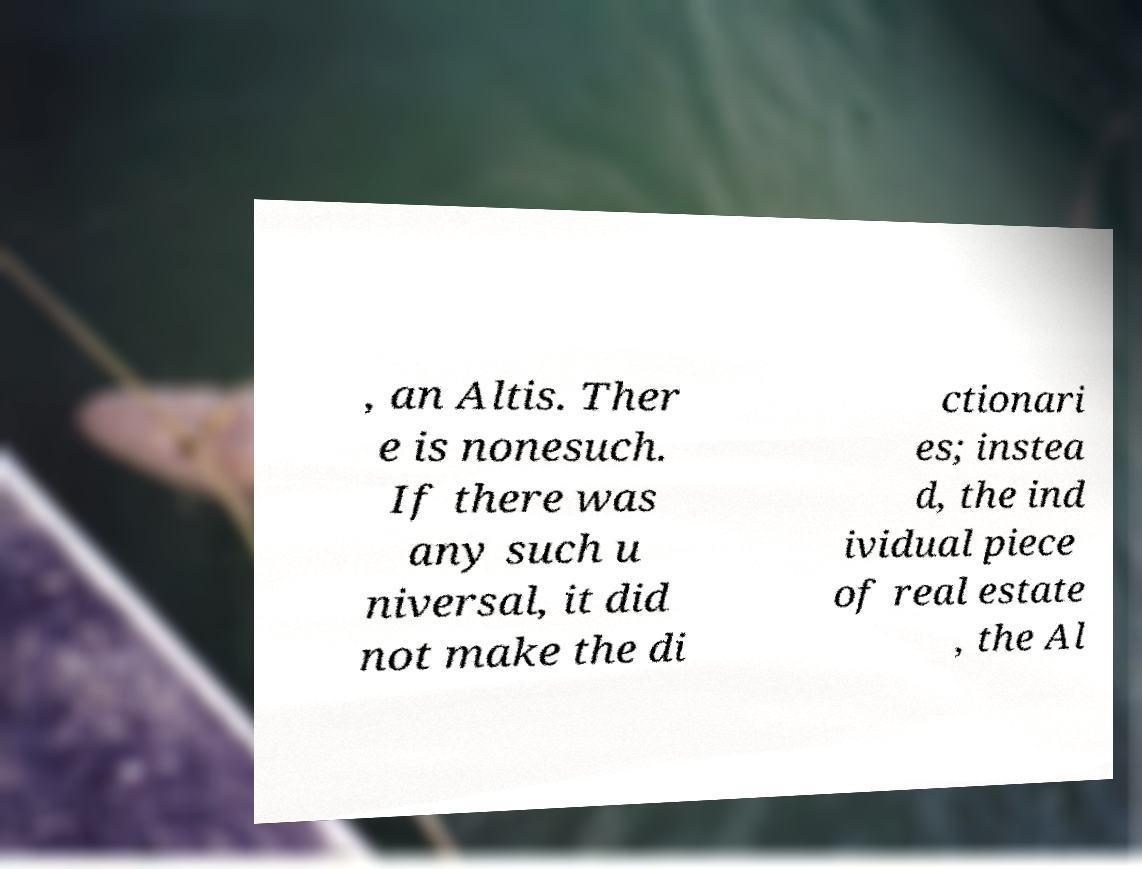What messages or text are displayed in this image? I need them in a readable, typed format. , an Altis. Ther e is nonesuch. If there was any such u niversal, it did not make the di ctionari es; instea d, the ind ividual piece of real estate , the Al 